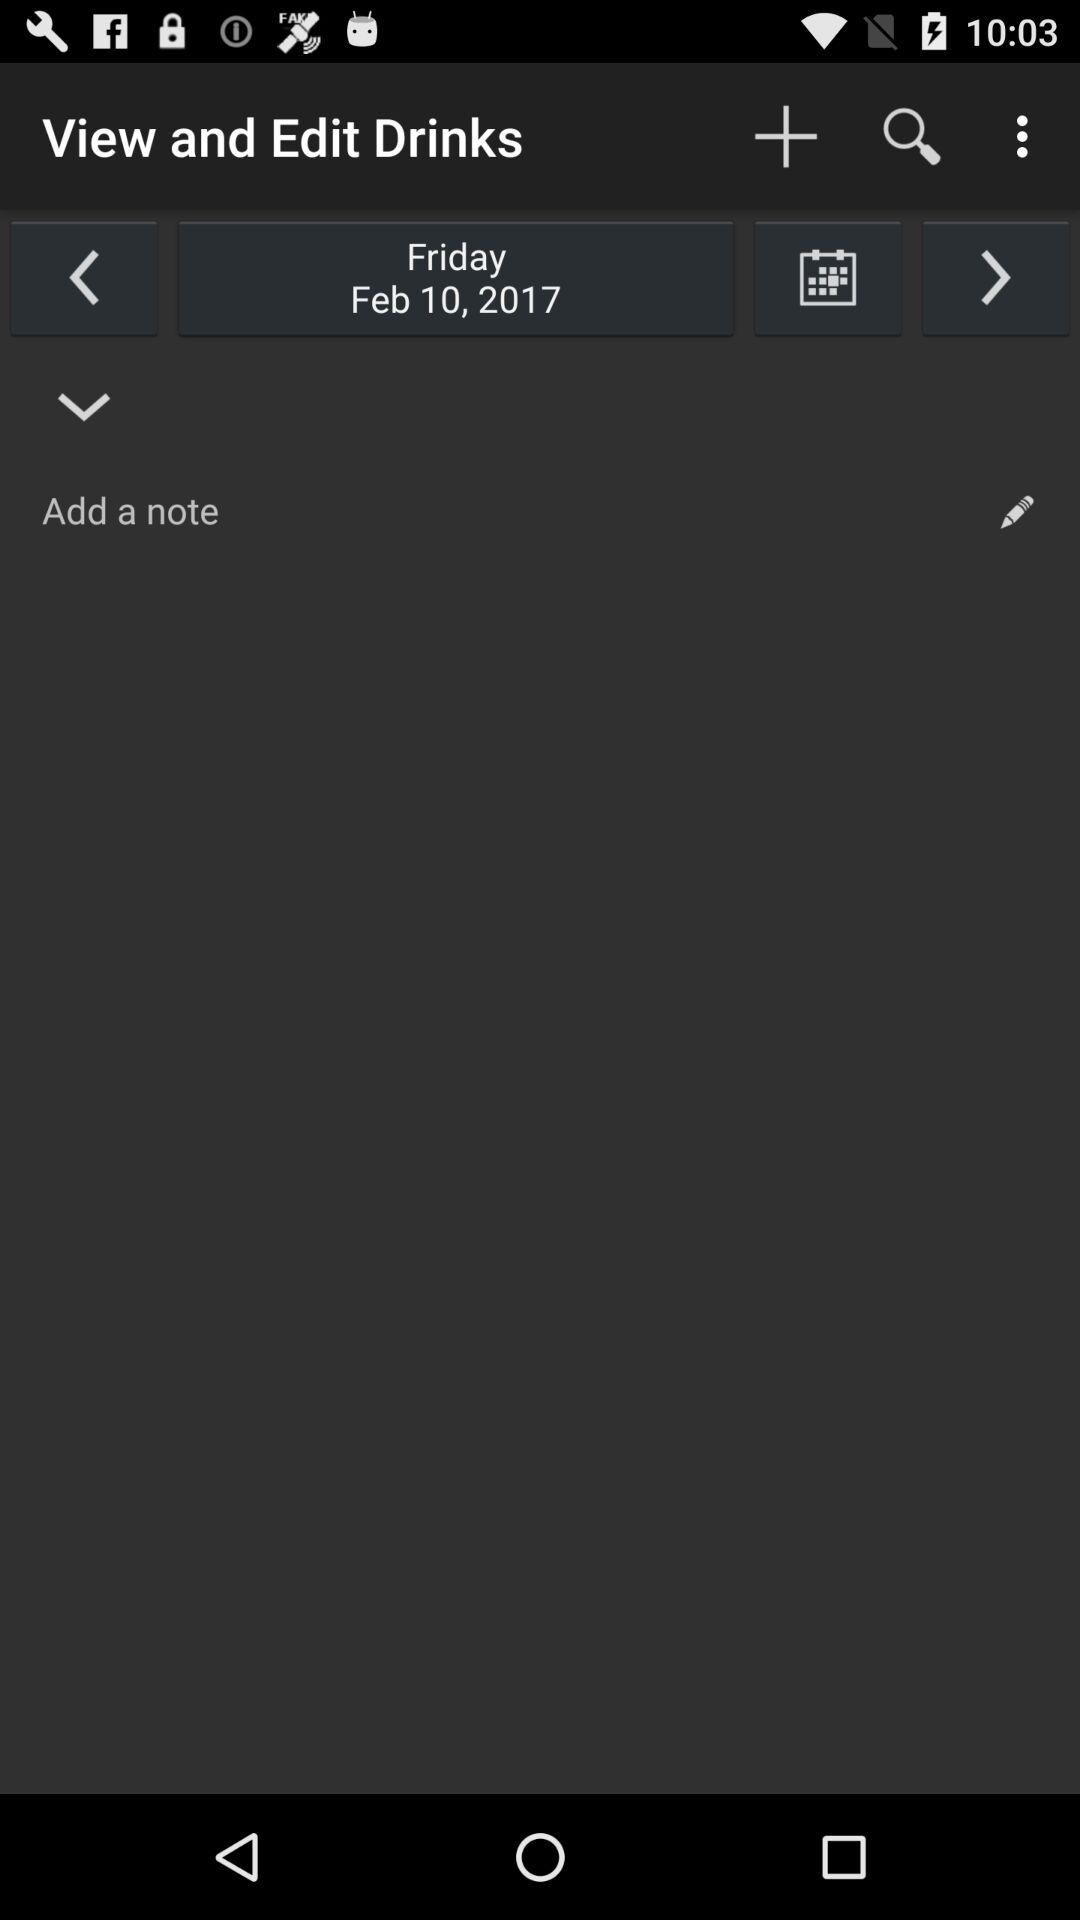What is the selected day? The selected day is Friday. 